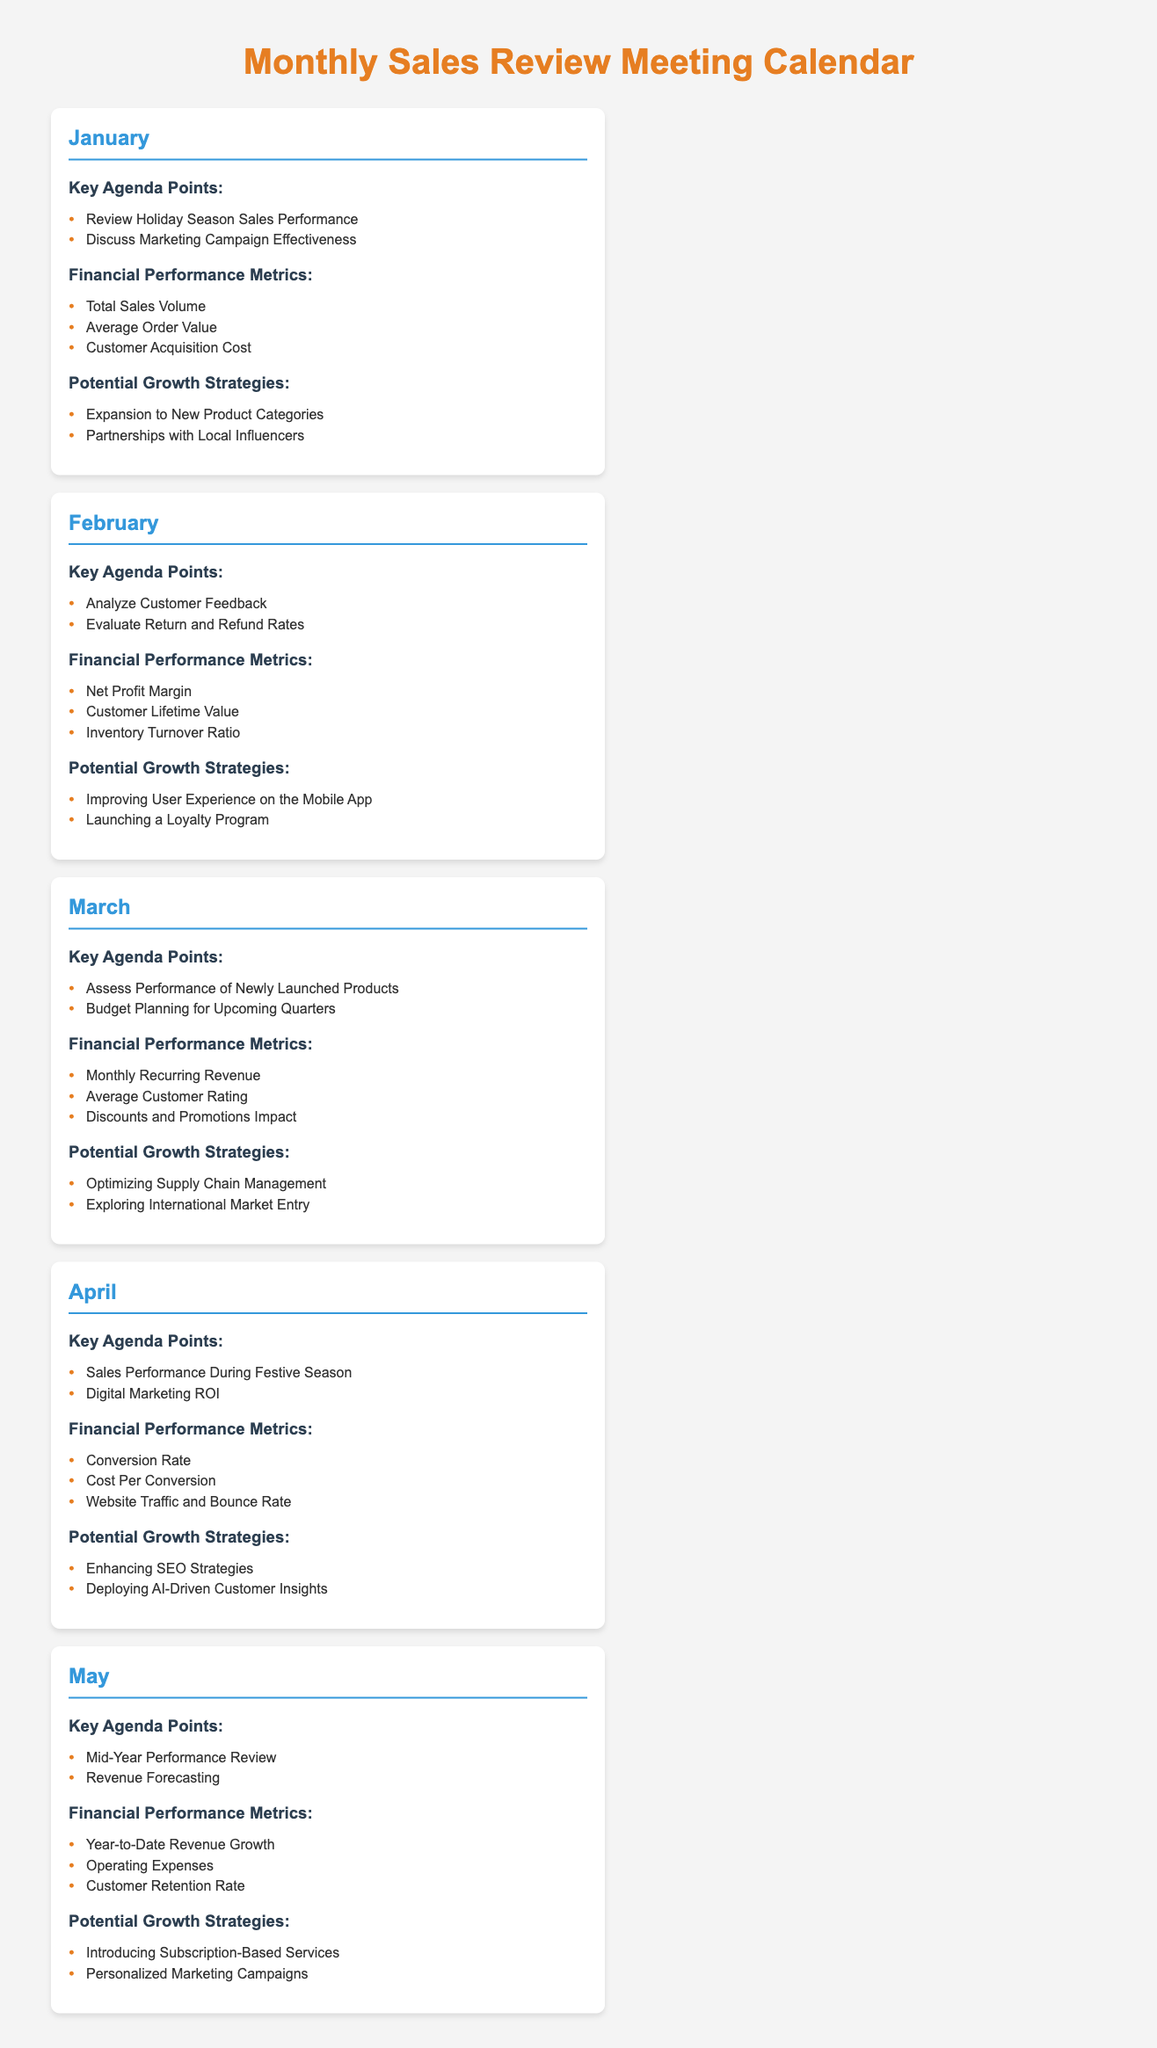What are the key agenda points for January? The key agenda points for January include reviewing holiday season sales performance and discussing marketing campaign effectiveness.
Answer: Review Holiday Season Sales Performance, Discuss Marketing Campaign Effectiveness What financial performance metric is assessed in February? One of the financial performance metrics assessed in February is the net profit margin.
Answer: Net Profit Margin What potential growth strategy is proposed for March? One potential growth strategy proposed for March is exploring international market entry.
Answer: Exploring International Market Entry How many key agenda points are listed for May? There are two key agenda points listed for May, indicating that the mid-year performance review and revenue forecasting will be discussed.
Answer: 2 What is the financial performance metric related to customer acquisition discussed in January? The customer acquisition cost is a financial performance metric related to customer acquisition discussed in January.
Answer: Customer Acquisition Cost What financial performance metrics are analyzed in April? In April, the financial performance metrics analyzed are conversion rate, cost per conversion, and website traffic and bounce rate.
Answer: Conversion Rate, Cost Per Conversion, Website Traffic and Bounce Rate Which month focuses on revenue forecasting? The month that focuses on revenue forecasting is May.
Answer: May What key agenda point appears in both January and April? The key agenda point that appears in both January and April is reviewing sales performance during peak periods.
Answer: Reviewing holiday season sales performance (January), Sales performance during festive season (April) What is the primary financial performance metric for March? The primary financial performance metric for March is monthly recurring revenue.
Answer: Monthly Recurring Revenue 